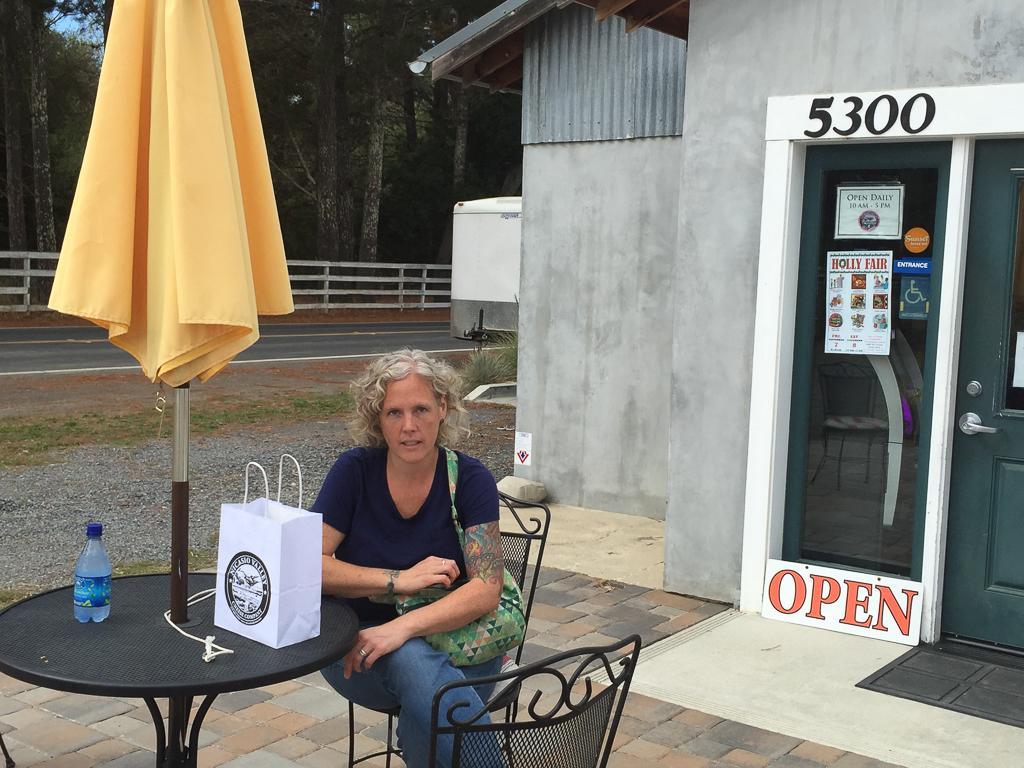Describe this image in one or two sentences. In this picture there is a lady who is sitting at the center of the image on the chair, by resting her hand on the table, there is a bottle and white bag on the table, it seems to be a road side, there are trees at the left side of the image and there is a house at the center of the image. 